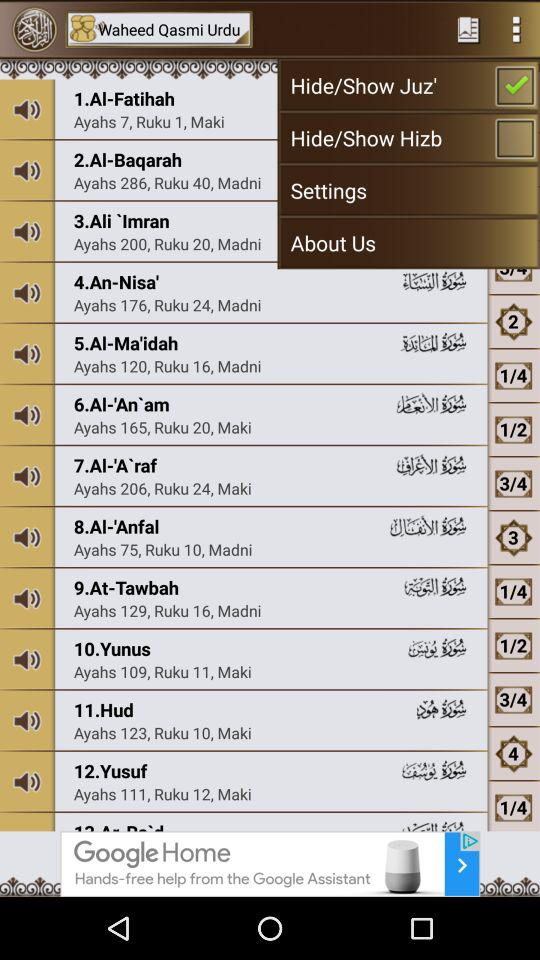What is the number of ayahs in "At-Tawbah"? The number of ayahs in "At-Tawbah" is 129. 